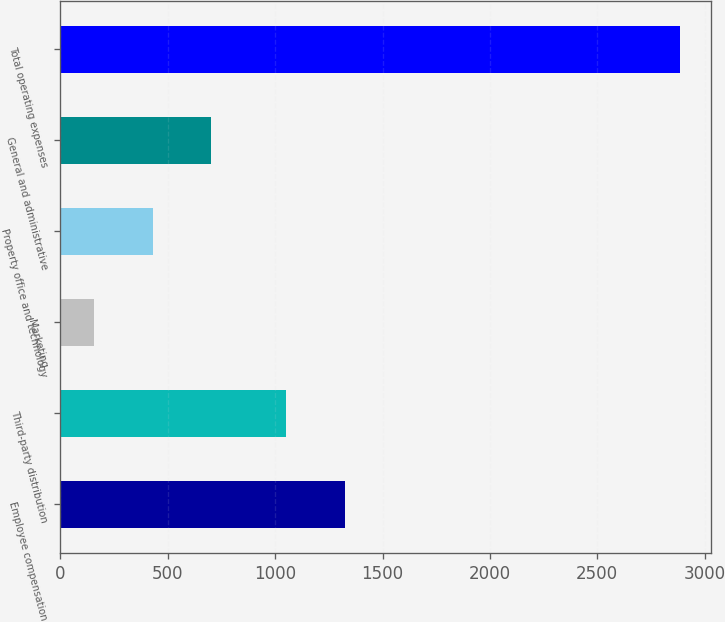<chart> <loc_0><loc_0><loc_500><loc_500><bar_chart><fcel>Employee compensation<fcel>Third-party distribution<fcel>Marketing<fcel>Property office and technology<fcel>General and administrative<fcel>Total operating expenses<nl><fcel>1323.8<fcel>1051.1<fcel>157.6<fcel>430.3<fcel>703<fcel>2884.6<nl></chart> 